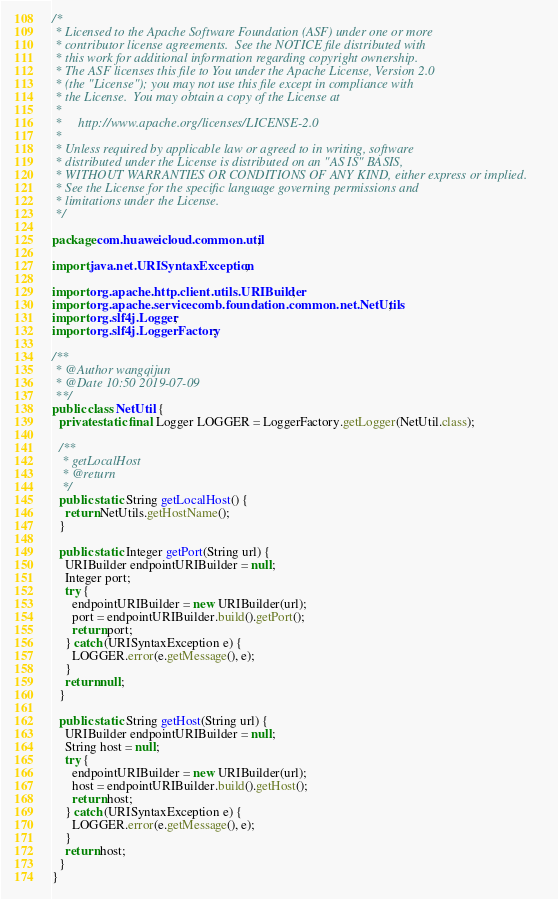Convert code to text. <code><loc_0><loc_0><loc_500><loc_500><_Java_>/*
 * Licensed to the Apache Software Foundation (ASF) under one or more
 * contributor license agreements.  See the NOTICE file distributed with
 * this work for additional information regarding copyright ownership.
 * The ASF licenses this file to You under the Apache License, Version 2.0
 * (the "License"); you may not use this file except in compliance with
 * the License.  You may obtain a copy of the License at
 *
 *     http://www.apache.org/licenses/LICENSE-2.0
 *
 * Unless required by applicable law or agreed to in writing, software
 * distributed under the License is distributed on an "AS IS" BASIS,
 * WITHOUT WARRANTIES OR CONDITIONS OF ANY KIND, either express or implied.
 * See the License for the specific language governing permissions and
 * limitations under the License.
 */

package com.huaweicloud.common.util;

import java.net.URISyntaxException;

import org.apache.http.client.utils.URIBuilder;
import org.apache.servicecomb.foundation.common.net.NetUtils;
import org.slf4j.Logger;
import org.slf4j.LoggerFactory;

/**
 * @Author wangqijun
 * @Date 10:50 2019-07-09
 **/
public class NetUtil {
  private static final Logger LOGGER = LoggerFactory.getLogger(NetUtil.class);

  /**
   * getLocalHost
   * @return
   */
  public static String getLocalHost() {
    return NetUtils.getHostName();
  }

  public static Integer getPort(String url) {
    URIBuilder endpointURIBuilder = null;
    Integer port;
    try {
      endpointURIBuilder = new URIBuilder(url);
      port = endpointURIBuilder.build().getPort();
      return port;
    } catch (URISyntaxException e) {
      LOGGER.error(e.getMessage(), e);
    }
    return null;
  }

  public static String getHost(String url) {
    URIBuilder endpointURIBuilder = null;
    String host = null;
    try {
      endpointURIBuilder = new URIBuilder(url);
      host = endpointURIBuilder.build().getHost();
      return host;
    } catch (URISyntaxException e) {
      LOGGER.error(e.getMessage(), e);
    }
    return host;
  }
}
</code> 